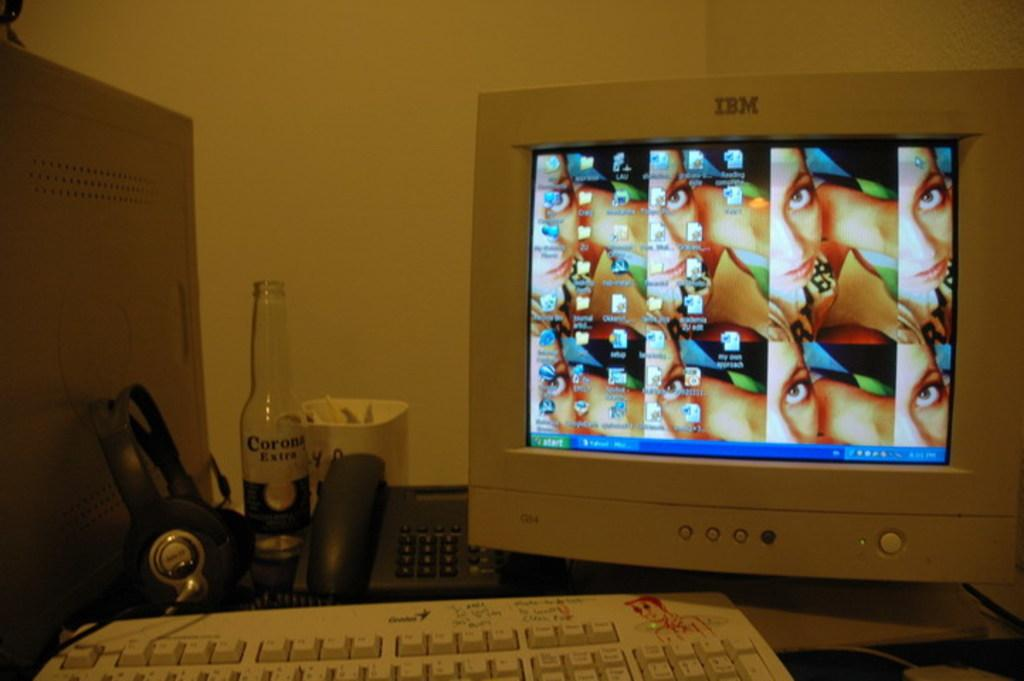<image>
Create a compact narrative representing the image presented. An IBM desktop computer on a desk with a bottle of Corona beside it. 